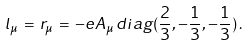Convert formula to latex. <formula><loc_0><loc_0><loc_500><loc_500>l _ { \mu } \, = \, r _ { \mu } \, = \, - e A _ { \mu } \, d i a g ( { \frac { 2 } { 3 } } , { - \frac { 1 } { 3 } } , { - \frac { 1 } { 3 } } ) \, .</formula> 